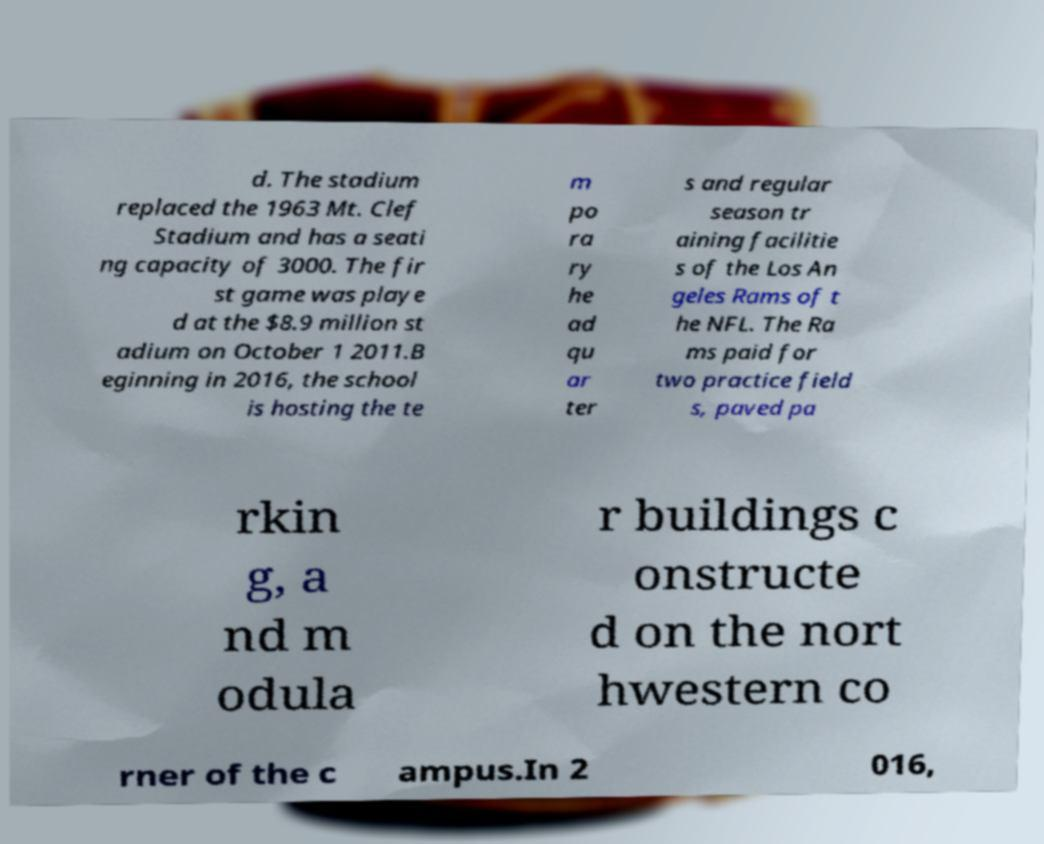For documentation purposes, I need the text within this image transcribed. Could you provide that? d. The stadium replaced the 1963 Mt. Clef Stadium and has a seati ng capacity of 3000. The fir st game was playe d at the $8.9 million st adium on October 1 2011.B eginning in 2016, the school is hosting the te m po ra ry he ad qu ar ter s and regular season tr aining facilitie s of the Los An geles Rams of t he NFL. The Ra ms paid for two practice field s, paved pa rkin g, a nd m odula r buildings c onstructe d on the nort hwestern co rner of the c ampus.In 2 016, 